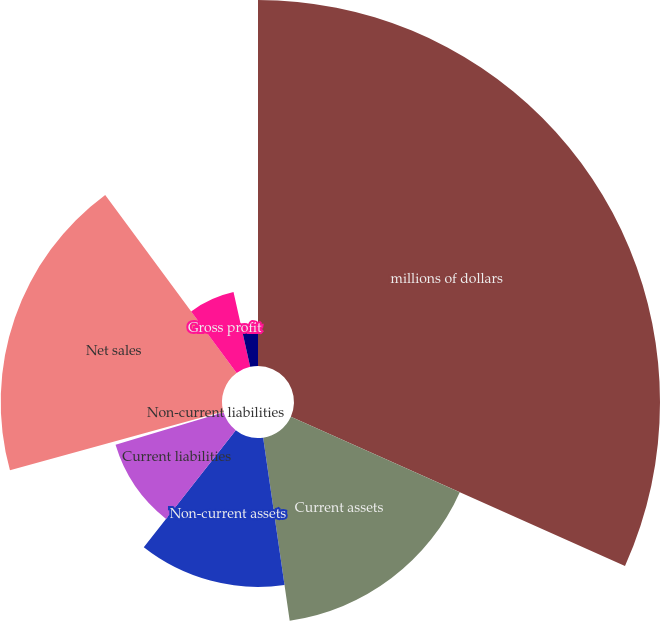Convert chart. <chart><loc_0><loc_0><loc_500><loc_500><pie_chart><fcel>millions of dollars<fcel>Current assets<fcel>Non-current assets<fcel>Current liabilities<fcel>Non-current liabilities<fcel>Net sales<fcel>Gross profit<fcel>Net income<nl><fcel>31.69%<fcel>16.02%<fcel>12.89%<fcel>9.76%<fcel>0.36%<fcel>19.16%<fcel>6.63%<fcel>3.49%<nl></chart> 